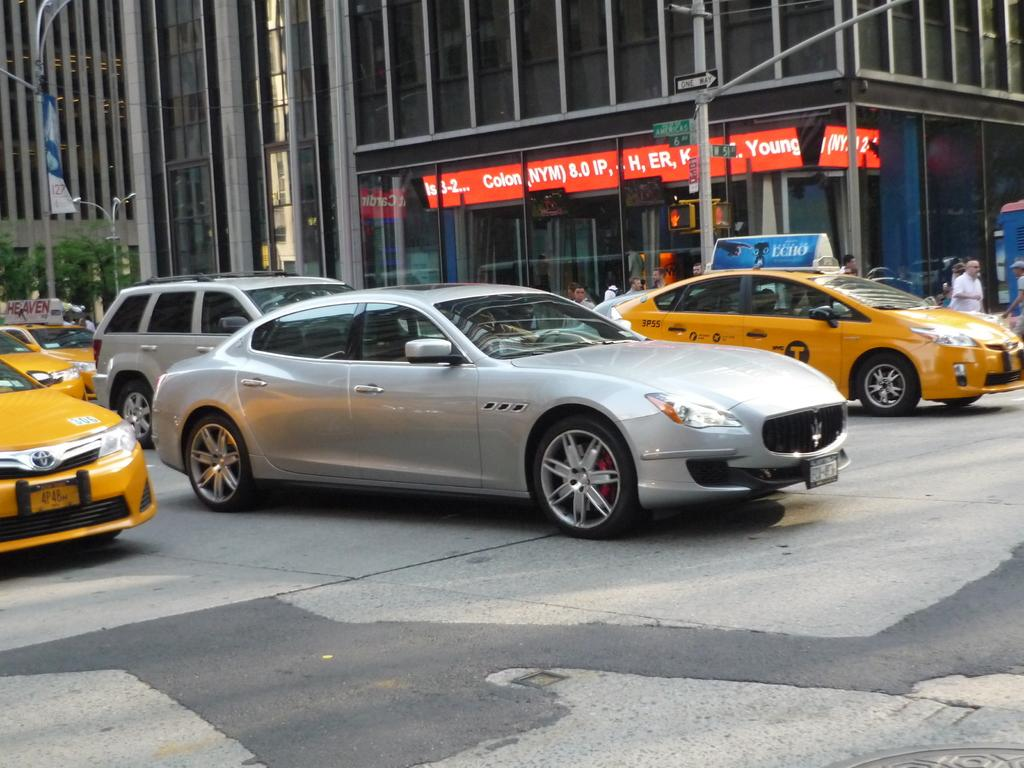What type of vehicles can be seen in the image? There are cars in the image. Who or what else is present in the image? There are persons in the image. What structures can be seen in the image? There are poles and buildings in the image. What type of natural elements are visible in the image or background? There are trees in the image or background. Is there any text visible in the image? Yes, there is text visible on a building. Where is the cart located in the image? There is no cart present in the image. What type of hydrant can be seen in the image? There is no hydrant present in the image. 